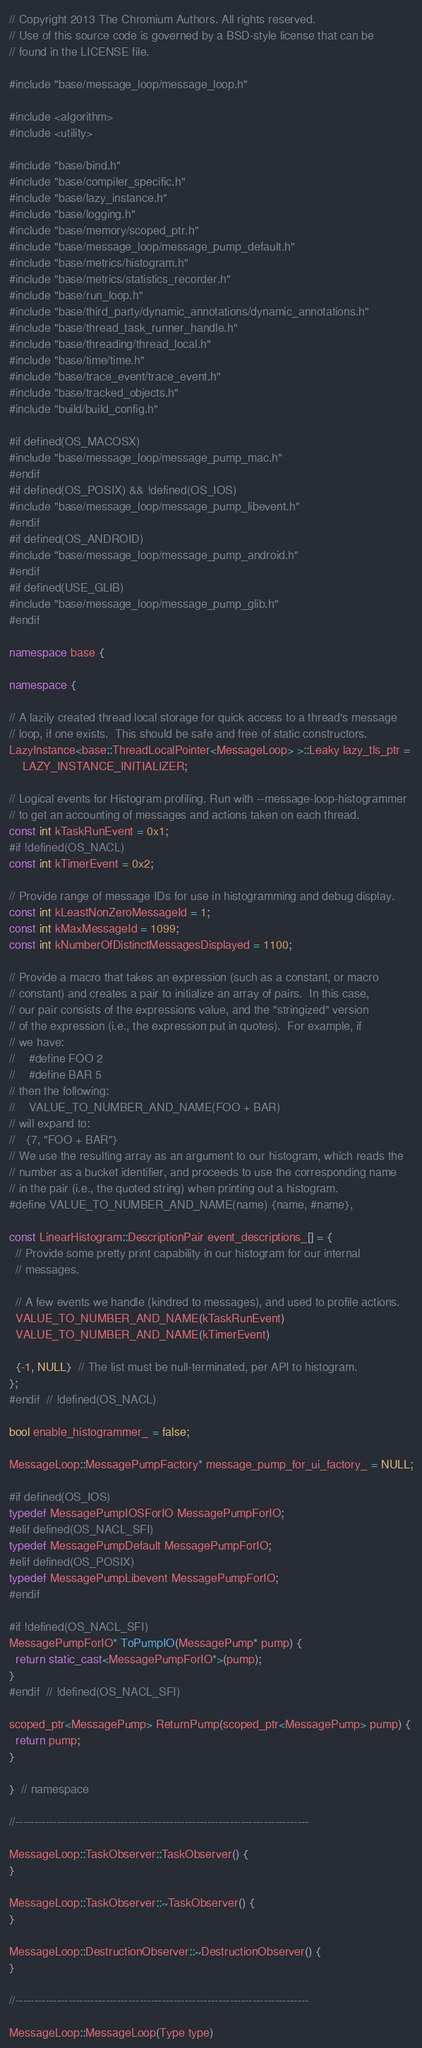<code> <loc_0><loc_0><loc_500><loc_500><_C++_>// Copyright 2013 The Chromium Authors. All rights reserved.
// Use of this source code is governed by a BSD-style license that can be
// found in the LICENSE file.

#include "base/message_loop/message_loop.h"

#include <algorithm>
#include <utility>

#include "base/bind.h"
#include "base/compiler_specific.h"
#include "base/lazy_instance.h"
#include "base/logging.h"
#include "base/memory/scoped_ptr.h"
#include "base/message_loop/message_pump_default.h"
#include "base/metrics/histogram.h"
#include "base/metrics/statistics_recorder.h"
#include "base/run_loop.h"
#include "base/third_party/dynamic_annotations/dynamic_annotations.h"
#include "base/thread_task_runner_handle.h"
#include "base/threading/thread_local.h"
#include "base/time/time.h"
#include "base/trace_event/trace_event.h"
#include "base/tracked_objects.h"
#include "build/build_config.h"

#if defined(OS_MACOSX)
#include "base/message_loop/message_pump_mac.h"
#endif
#if defined(OS_POSIX) && !defined(OS_IOS)
#include "base/message_loop/message_pump_libevent.h"
#endif
#if defined(OS_ANDROID)
#include "base/message_loop/message_pump_android.h"
#endif
#if defined(USE_GLIB)
#include "base/message_loop/message_pump_glib.h"
#endif

namespace base {

namespace {

// A lazily created thread local storage for quick access to a thread's message
// loop, if one exists.  This should be safe and free of static constructors.
LazyInstance<base::ThreadLocalPointer<MessageLoop> >::Leaky lazy_tls_ptr =
    LAZY_INSTANCE_INITIALIZER;

// Logical events for Histogram profiling. Run with --message-loop-histogrammer
// to get an accounting of messages and actions taken on each thread.
const int kTaskRunEvent = 0x1;
#if !defined(OS_NACL)
const int kTimerEvent = 0x2;

// Provide range of message IDs for use in histogramming and debug display.
const int kLeastNonZeroMessageId = 1;
const int kMaxMessageId = 1099;
const int kNumberOfDistinctMessagesDisplayed = 1100;

// Provide a macro that takes an expression (such as a constant, or macro
// constant) and creates a pair to initialize an array of pairs.  In this case,
// our pair consists of the expressions value, and the "stringized" version
// of the expression (i.e., the expression put in quotes).  For example, if
// we have:
//    #define FOO 2
//    #define BAR 5
// then the following:
//    VALUE_TO_NUMBER_AND_NAME(FOO + BAR)
// will expand to:
//   {7, "FOO + BAR"}
// We use the resulting array as an argument to our histogram, which reads the
// number as a bucket identifier, and proceeds to use the corresponding name
// in the pair (i.e., the quoted string) when printing out a histogram.
#define VALUE_TO_NUMBER_AND_NAME(name) {name, #name},

const LinearHistogram::DescriptionPair event_descriptions_[] = {
  // Provide some pretty print capability in our histogram for our internal
  // messages.

  // A few events we handle (kindred to messages), and used to profile actions.
  VALUE_TO_NUMBER_AND_NAME(kTaskRunEvent)
  VALUE_TO_NUMBER_AND_NAME(kTimerEvent)

  {-1, NULL}  // The list must be null-terminated, per API to histogram.
};
#endif  // !defined(OS_NACL)

bool enable_histogrammer_ = false;

MessageLoop::MessagePumpFactory* message_pump_for_ui_factory_ = NULL;

#if defined(OS_IOS)
typedef MessagePumpIOSForIO MessagePumpForIO;
#elif defined(OS_NACL_SFI)
typedef MessagePumpDefault MessagePumpForIO;
#elif defined(OS_POSIX)
typedef MessagePumpLibevent MessagePumpForIO;
#endif

#if !defined(OS_NACL_SFI)
MessagePumpForIO* ToPumpIO(MessagePump* pump) {
  return static_cast<MessagePumpForIO*>(pump);
}
#endif  // !defined(OS_NACL_SFI)

scoped_ptr<MessagePump> ReturnPump(scoped_ptr<MessagePump> pump) {
  return pump;
}

}  // namespace

//------------------------------------------------------------------------------

MessageLoop::TaskObserver::TaskObserver() {
}

MessageLoop::TaskObserver::~TaskObserver() {
}

MessageLoop::DestructionObserver::~DestructionObserver() {
}

//------------------------------------------------------------------------------

MessageLoop::MessageLoop(Type type)</code> 